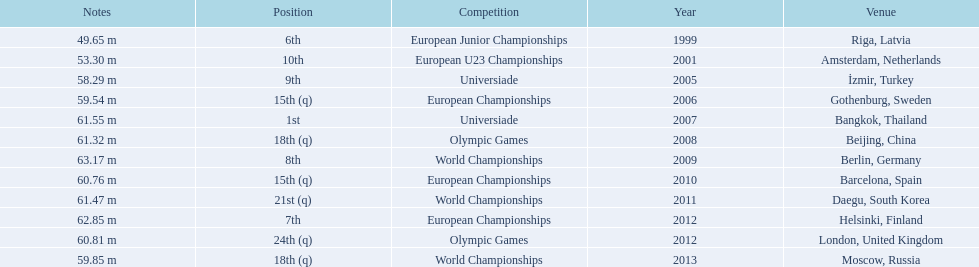What are the years that gerhard mayer participated? 1999, 2001, 2005, 2006, 2007, 2008, 2009, 2010, 2011, 2012, 2012, 2013. Which years were earlier than 2007? 1999, 2001, 2005, 2006. What was the best placing for these years? 6th. 